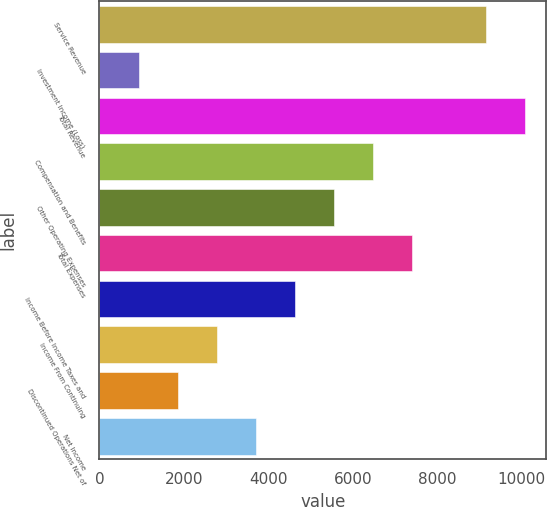Convert chart to OTSL. <chart><loc_0><loc_0><loc_500><loc_500><bar_chart><fcel>Service Revenue<fcel>Investment Income (Loss)<fcel>Total Revenue<fcel>Compensation and Benefits<fcel>Other Operating Expenses<fcel>Total Expenses<fcel>Income Before Income Taxes and<fcel>Income From Continuing<fcel>Discontinued Operations Net of<fcel>Net Income<nl><fcel>9156<fcel>926.36<fcel>10081.2<fcel>6477.44<fcel>5552.26<fcel>7402.62<fcel>4627.08<fcel>2776.72<fcel>1851.54<fcel>3701.9<nl></chart> 